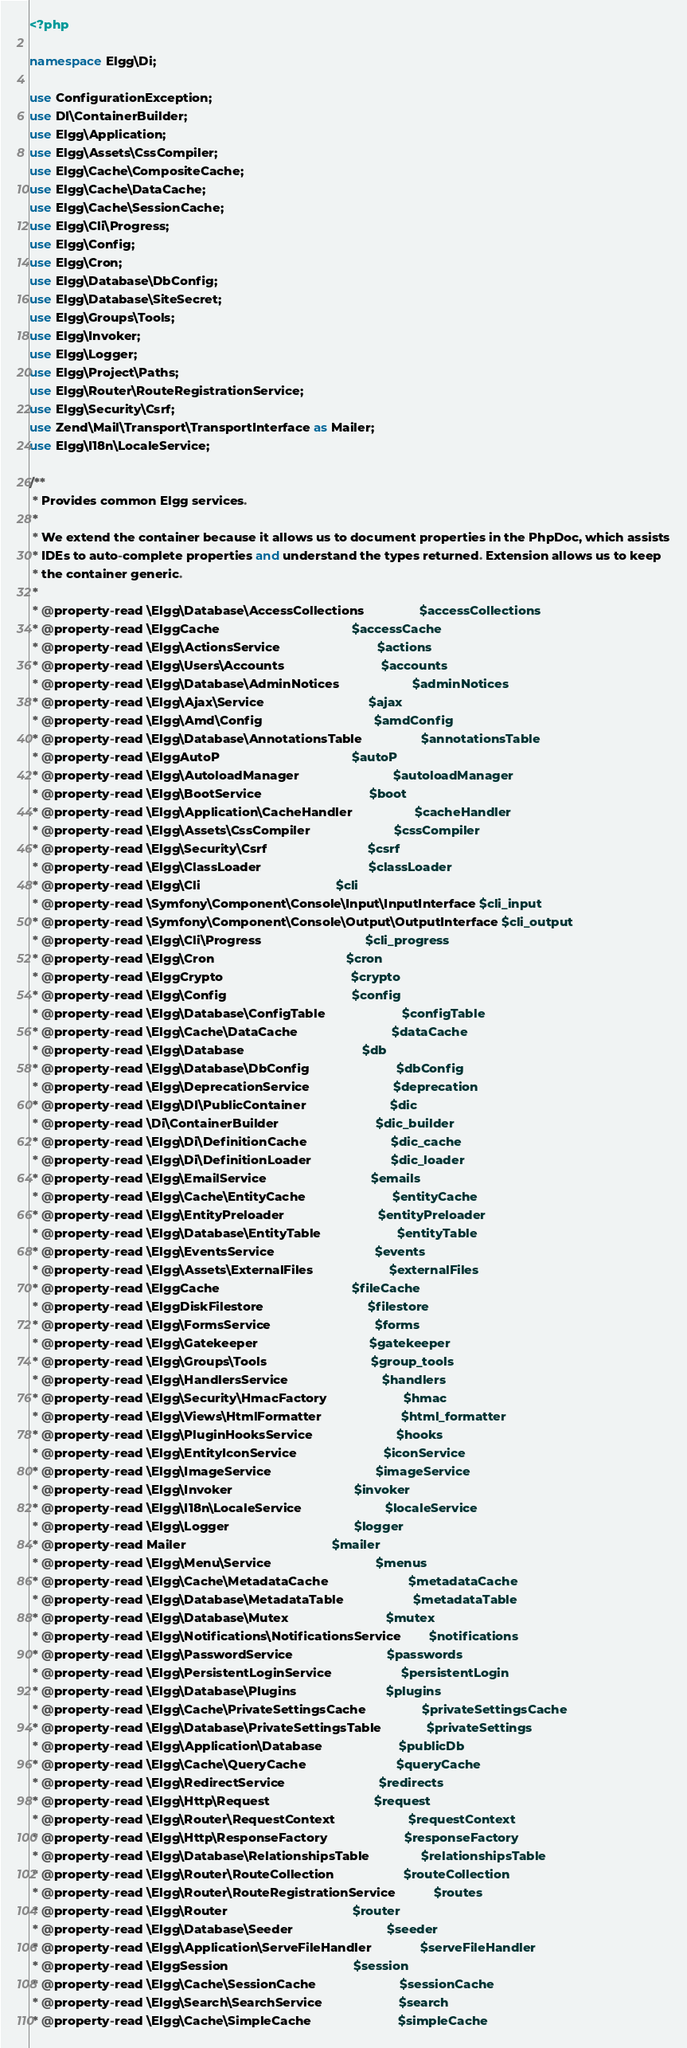Convert code to text. <code><loc_0><loc_0><loc_500><loc_500><_PHP_><?php

namespace Elgg\Di;

use ConfigurationException;
use DI\ContainerBuilder;
use Elgg\Application;
use Elgg\Assets\CssCompiler;
use Elgg\Cache\CompositeCache;
use Elgg\Cache\DataCache;
use Elgg\Cache\SessionCache;
use Elgg\Cli\Progress;
use Elgg\Config;
use Elgg\Cron;
use Elgg\Database\DbConfig;
use Elgg\Database\SiteSecret;
use Elgg\Groups\Tools;
use Elgg\Invoker;
use Elgg\Logger;
use Elgg\Project\Paths;
use Elgg\Router\RouteRegistrationService;
use Elgg\Security\Csrf;
use Zend\Mail\Transport\TransportInterface as Mailer;
use Elgg\I18n\LocaleService;

/**
 * Provides common Elgg services.
 *
 * We extend the container because it allows us to document properties in the PhpDoc, which assists
 * IDEs to auto-complete properties and understand the types returned. Extension allows us to keep
 * the container generic.
 *
 * @property-read \Elgg\Database\AccessCollections                $accessCollections
 * @property-read \ElggCache                                      $accessCache
 * @property-read \Elgg\ActionsService                            $actions
 * @property-read \Elgg\Users\Accounts                            $accounts
 * @property-read \Elgg\Database\AdminNotices                     $adminNotices
 * @property-read \Elgg\Ajax\Service                              $ajax
 * @property-read \Elgg\Amd\Config                                $amdConfig
 * @property-read \Elgg\Database\AnnotationsTable                 $annotationsTable
 * @property-read \ElggAutoP                                      $autoP
 * @property-read \Elgg\AutoloadManager                           $autoloadManager
 * @property-read \Elgg\BootService                               $boot
 * @property-read \Elgg\Application\CacheHandler                  $cacheHandler
 * @property-read \Elgg\Assets\CssCompiler                        $cssCompiler
 * @property-read \Elgg\Security\Csrf                             $csrf
 * @property-read \Elgg\ClassLoader                               $classLoader
 * @property-read \Elgg\Cli                                       $cli
 * @property-read \Symfony\Component\Console\Input\InputInterface $cli_input
 * @property-read \Symfony\Component\Console\Output\OutputInterface $cli_output
 * @property-read \Elgg\Cli\Progress                              $cli_progress
 * @property-read \Elgg\Cron                                      $cron
 * @property-read \ElggCrypto                                     $crypto
 * @property-read \Elgg\Config                                    $config
 * @property-read \Elgg\Database\ConfigTable                      $configTable
 * @property-read \Elgg\Cache\DataCache                           $dataCache
 * @property-read \Elgg\Database                                  $db
 * @property-read \Elgg\Database\DbConfig                         $dbConfig
 * @property-read \Elgg\DeprecationService                        $deprecation
 * @property-read \Elgg\DI\PublicContainer                        $dic
 * @property-read \Di\ContainerBuilder                            $dic_builder
 * @property-read \Elgg\Di\DefinitionCache                        $dic_cache
 * @property-read \Elgg\Di\DefinitionLoader                       $dic_loader
 * @property-read \Elgg\EmailService                              $emails
 * @property-read \Elgg\Cache\EntityCache                         $entityCache
 * @property-read \Elgg\EntityPreloader                           $entityPreloader
 * @property-read \Elgg\Database\EntityTable                      $entityTable
 * @property-read \Elgg\EventsService                             $events
 * @property-read \Elgg\Assets\ExternalFiles                      $externalFiles
 * @property-read \ElggCache                                      $fileCache
 * @property-read \ElggDiskFilestore                              $filestore
 * @property-read \Elgg\FormsService                              $forms
 * @property-read \Elgg\Gatekeeper                                $gatekeeper
 * @property-read \Elgg\Groups\Tools                              $group_tools
 * @property-read \Elgg\HandlersService                           $handlers
 * @property-read \Elgg\Security\HmacFactory                      $hmac
 * @property-read \Elgg\Views\HtmlFormatter                       $html_formatter
 * @property-read \Elgg\PluginHooksService                        $hooks
 * @property-read \Elgg\EntityIconService                         $iconService
 * @property-read \Elgg\ImageService                              $imageService
 * @property-read \Elgg\Invoker                                   $invoker
 * @property-read \Elgg\I18n\LocaleService                        $localeService
 * @property-read \Elgg\Logger                                    $logger
 * @property-read Mailer                                          $mailer
 * @property-read \Elgg\Menu\Service                              $menus
 * @property-read \Elgg\Cache\MetadataCache                       $metadataCache
 * @property-read \Elgg\Database\MetadataTable                    $metadataTable
 * @property-read \Elgg\Database\Mutex                            $mutex
 * @property-read \Elgg\Notifications\NotificationsService        $notifications
 * @property-read \Elgg\PasswordService                           $passwords
 * @property-read \Elgg\PersistentLoginService                    $persistentLogin
 * @property-read \Elgg\Database\Plugins                          $plugins
 * @property-read \Elgg\Cache\PrivateSettingsCache                $privateSettingsCache
 * @property-read \Elgg\Database\PrivateSettingsTable             $privateSettings
 * @property-read \Elgg\Application\Database                      $publicDb
 * @property-read \Elgg\Cache\QueryCache                          $queryCache
 * @property-read \Elgg\RedirectService                           $redirects
 * @property-read \Elgg\Http\Request                              $request
 * @property-read \Elgg\Router\RequestContext                     $requestContext
 * @property-read \Elgg\Http\ResponseFactory                      $responseFactory
 * @property-read \Elgg\Database\RelationshipsTable               $relationshipsTable
 * @property-read \Elgg\Router\RouteCollection                    $routeCollection
 * @property-read \Elgg\Router\RouteRegistrationService           $routes
 * @property-read \Elgg\Router                                    $router
 * @property-read \Elgg\Database\Seeder                           $seeder
 * @property-read \Elgg\Application\ServeFileHandler              $serveFileHandler
 * @property-read \ElggSession                                    $session
 * @property-read \Elgg\Cache\SessionCache                        $sessionCache
 * @property-read \Elgg\Search\SearchService                      $search
 * @property-read \Elgg\Cache\SimpleCache                         $simpleCache</code> 